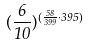<formula> <loc_0><loc_0><loc_500><loc_500>( \frac { 6 } { 1 0 } ) ^ { ( \frac { 5 8 } { 3 9 9 } \cdot 3 9 5 ) }</formula> 